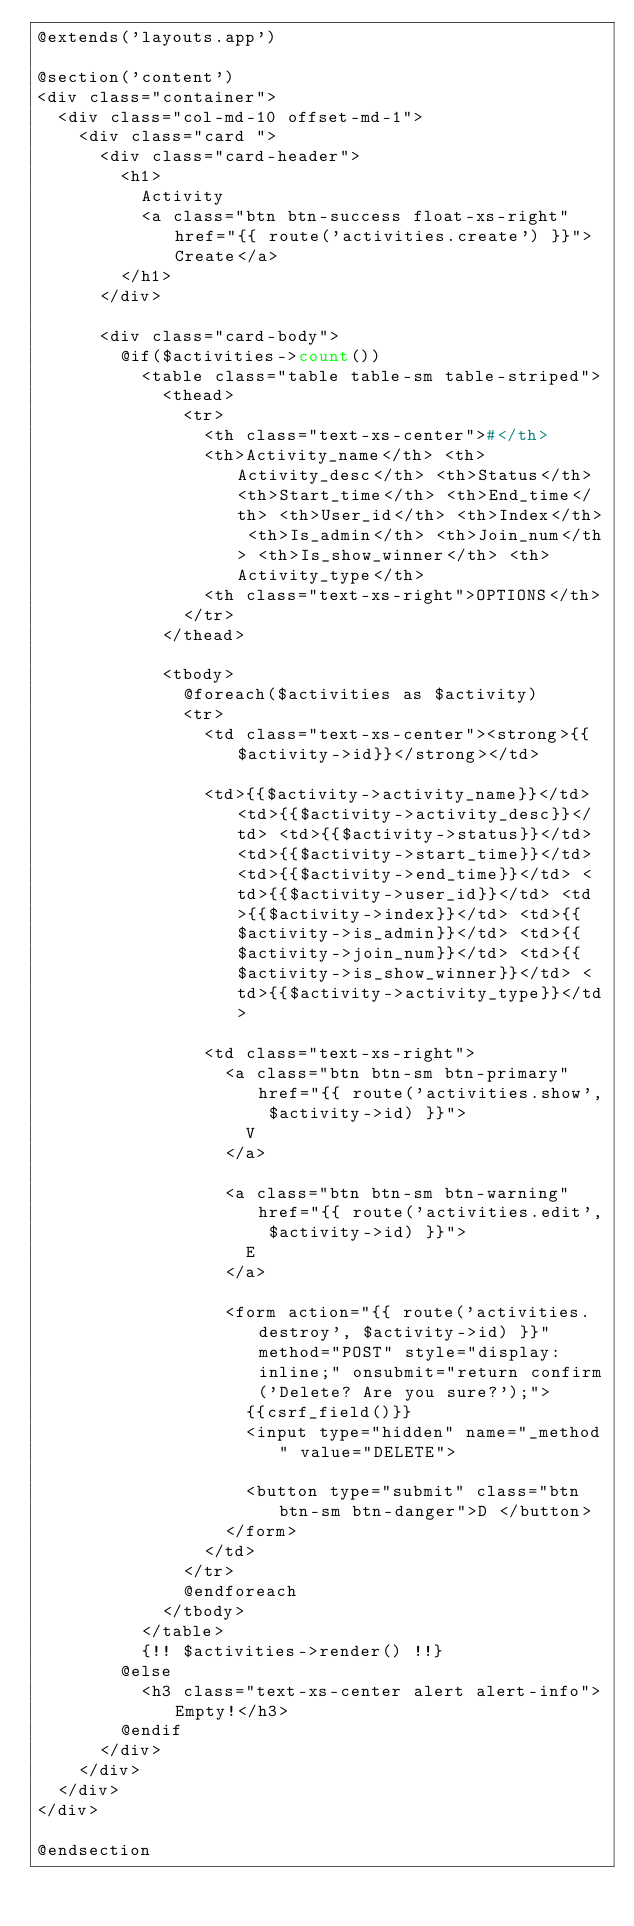Convert code to text. <code><loc_0><loc_0><loc_500><loc_500><_PHP_>@extends('layouts.app')

@section('content')
<div class="container">
  <div class="col-md-10 offset-md-1">
    <div class="card ">
      <div class="card-header">
        <h1>
          Activity
          <a class="btn btn-success float-xs-right" href="{{ route('activities.create') }}">Create</a>
        </h1>
      </div>

      <div class="card-body">
        @if($activities->count())
          <table class="table table-sm table-striped">
            <thead>
              <tr>
                <th class="text-xs-center">#</th>
                <th>Activity_name</th> <th>Activity_desc</th> <th>Status</th> <th>Start_time</th> <th>End_time</th> <th>User_id</th> <th>Index</th> <th>Is_admin</th> <th>Join_num</th> <th>Is_show_winner</th> <th>Activity_type</th>
                <th class="text-xs-right">OPTIONS</th>
              </tr>
            </thead>

            <tbody>
              @foreach($activities as $activity)
              <tr>
                <td class="text-xs-center"><strong>{{$activity->id}}</strong></td>

                <td>{{$activity->activity_name}}</td> <td>{{$activity->activity_desc}}</td> <td>{{$activity->status}}</td> <td>{{$activity->start_time}}</td> <td>{{$activity->end_time}}</td> <td>{{$activity->user_id}}</td> <td>{{$activity->index}}</td> <td>{{$activity->is_admin}}</td> <td>{{$activity->join_num}}</td> <td>{{$activity->is_show_winner}}</td> <td>{{$activity->activity_type}}</td>

                <td class="text-xs-right">
                  <a class="btn btn-sm btn-primary" href="{{ route('activities.show', $activity->id) }}">
                    V
                  </a>

                  <a class="btn btn-sm btn-warning" href="{{ route('activities.edit', $activity->id) }}">
                    E
                  </a>

                  <form action="{{ route('activities.destroy', $activity->id) }}" method="POST" style="display: inline;" onsubmit="return confirm('Delete? Are you sure?');">
                    {{csrf_field()}}
                    <input type="hidden" name="_method" value="DELETE">

                    <button type="submit" class="btn btn-sm btn-danger">D </button>
                  </form>
                </td>
              </tr>
              @endforeach
            </tbody>
          </table>
          {!! $activities->render() !!}
        @else
          <h3 class="text-xs-center alert alert-info">Empty!</h3>
        @endif
      </div>
    </div>
  </div>
</div>

@endsection
</code> 